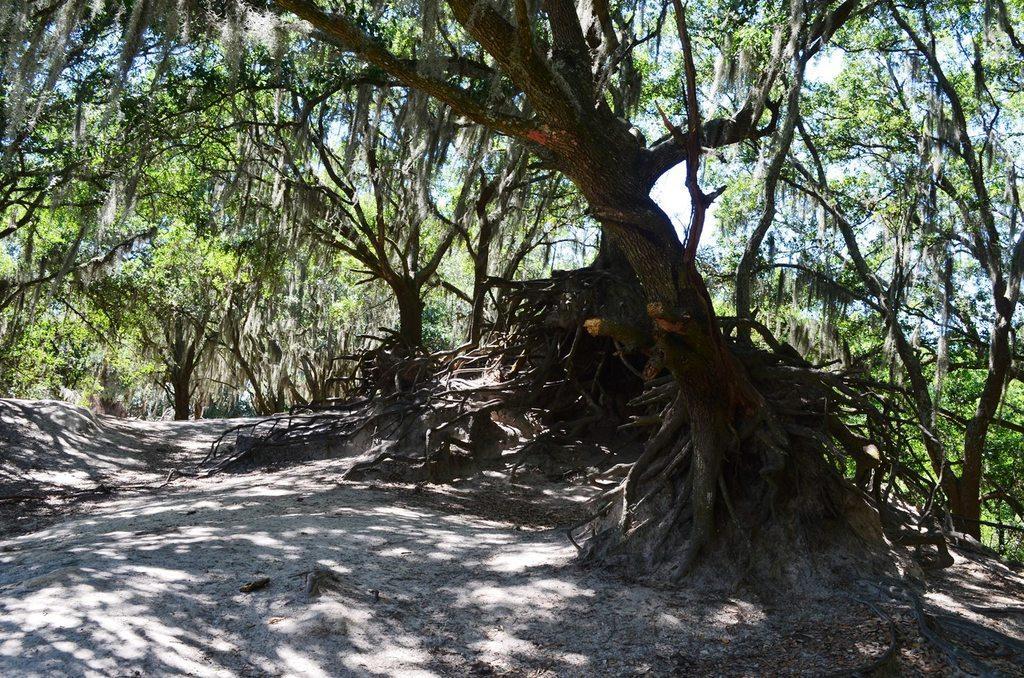Could you give a brief overview of what you see in this image? In the foreground of the picture there is soil. In the central of the picture there are trees and roots of the tree. It is sunny. 